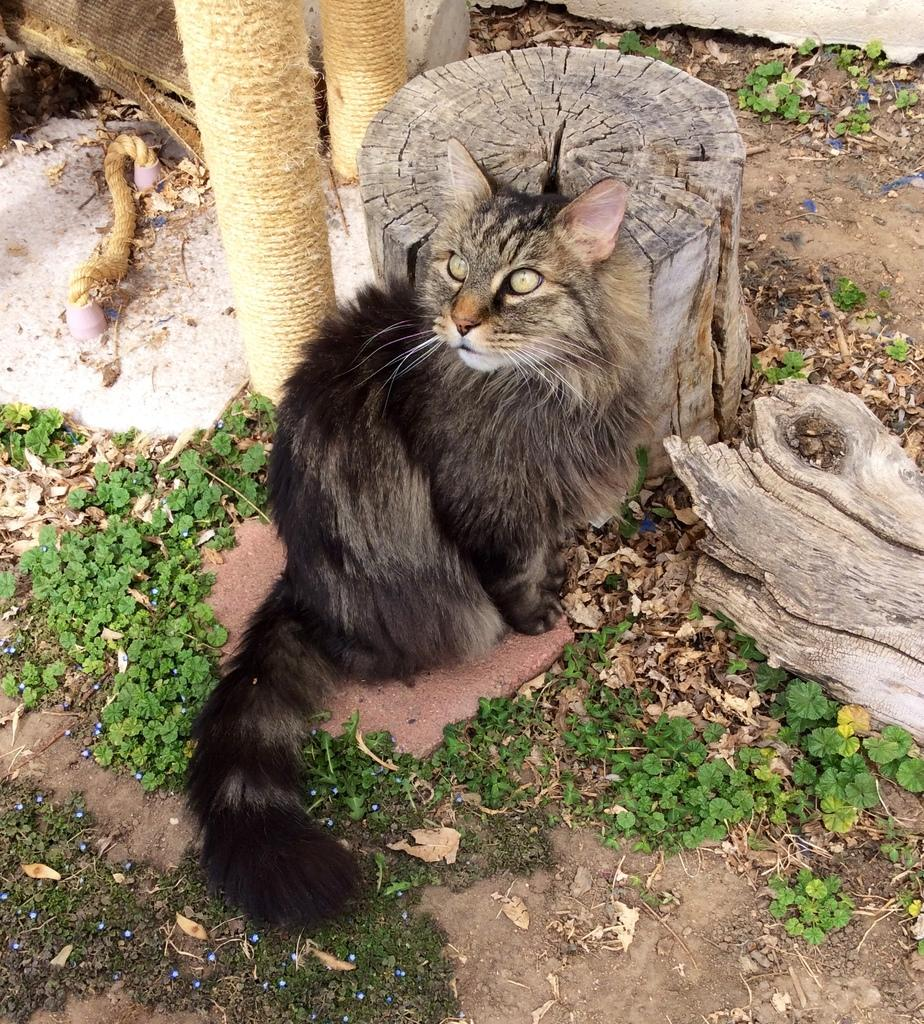What is the main subject in the center of the image? There is a cat in the center of the image. What can be seen at the top side of the image? There is a log at the top side of the image. What type of vegetation is present on the ground? There are baby plants on the ground. What type of train can be seen in the background of the image? There is no train present in the image; it only features a cat, a log, and baby plants. 